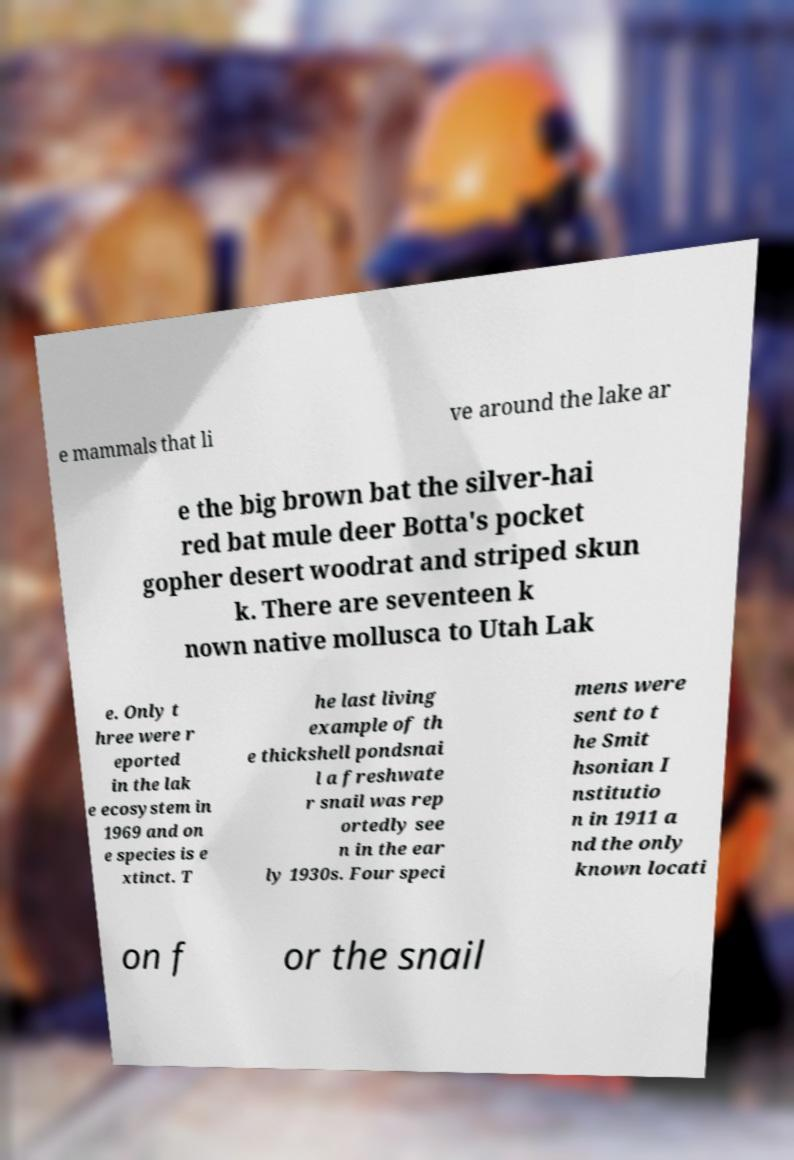Could you assist in decoding the text presented in this image and type it out clearly? e mammals that li ve around the lake ar e the big brown bat the silver-hai red bat mule deer Botta's pocket gopher desert woodrat and striped skun k. There are seventeen k nown native mollusca to Utah Lak e. Only t hree were r eported in the lak e ecosystem in 1969 and on e species is e xtinct. T he last living example of th e thickshell pondsnai l a freshwate r snail was rep ortedly see n in the ear ly 1930s. Four speci mens were sent to t he Smit hsonian I nstitutio n in 1911 a nd the only known locati on f or the snail 